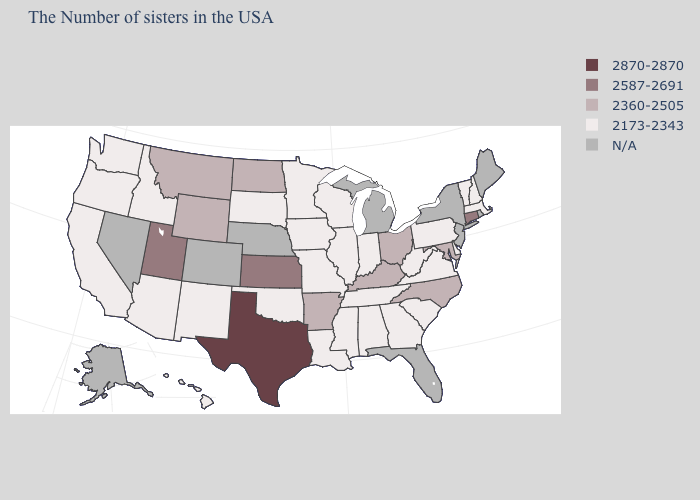Name the states that have a value in the range 2173-2343?
Answer briefly. Massachusetts, New Hampshire, Vermont, Delaware, Pennsylvania, Virginia, South Carolina, West Virginia, Georgia, Indiana, Alabama, Tennessee, Wisconsin, Illinois, Mississippi, Louisiana, Missouri, Minnesota, Iowa, Oklahoma, South Dakota, New Mexico, Arizona, Idaho, California, Washington, Oregon, Hawaii. Which states have the highest value in the USA?
Be succinct. Texas. What is the value of Washington?
Write a very short answer. 2173-2343. What is the value of New Jersey?
Quick response, please. N/A. Is the legend a continuous bar?
Concise answer only. No. Which states have the lowest value in the West?
Answer briefly. New Mexico, Arizona, Idaho, California, Washington, Oregon, Hawaii. Name the states that have a value in the range 2360-2505?
Answer briefly. Maryland, North Carolina, Ohio, Kentucky, Arkansas, North Dakota, Wyoming, Montana. What is the lowest value in the MidWest?
Keep it brief. 2173-2343. Does the map have missing data?
Answer briefly. Yes. What is the value of California?
Concise answer only. 2173-2343. Does the first symbol in the legend represent the smallest category?
Answer briefly. No. Name the states that have a value in the range N/A?
Concise answer only. Maine, Rhode Island, New York, New Jersey, Florida, Michigan, Nebraska, Colorado, Nevada, Alaska. What is the value of Delaware?
Answer briefly. 2173-2343. Which states have the lowest value in the USA?
Short answer required. Massachusetts, New Hampshire, Vermont, Delaware, Pennsylvania, Virginia, South Carolina, West Virginia, Georgia, Indiana, Alabama, Tennessee, Wisconsin, Illinois, Mississippi, Louisiana, Missouri, Minnesota, Iowa, Oklahoma, South Dakota, New Mexico, Arizona, Idaho, California, Washington, Oregon, Hawaii. 